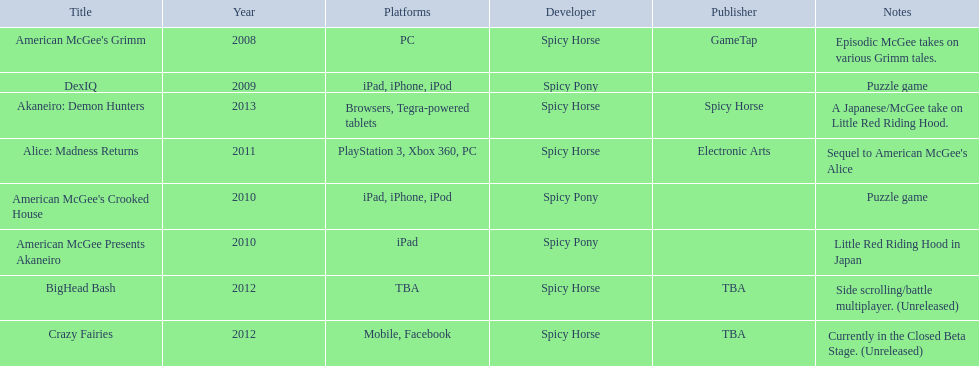Referring to the table, what is the most recent title developed by spicy horse? Akaneiro: Demon Hunters. 